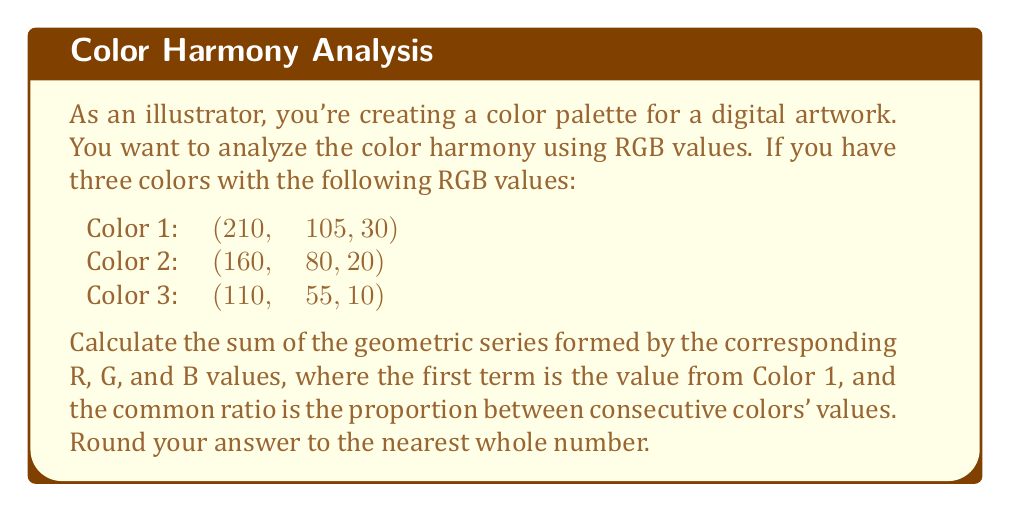Show me your answer to this math problem. Let's approach this step-by-step:

1) First, we need to identify the common ratio (r) for each color channel:

   For R: $r_R = 160/210 = 110/160 \approx 0.7619$
   For G: $r_G = 80/105 = 55/80 \approx 0.7619$
   For B: $r_B = 20/30 = 10/20 \approx 0.6667$

2) Now, we have three geometric series:
   
   R: $210 + 210(0.7619) + 210(0.7619)^2 + ...$
   G: $105 + 105(0.7619) + 105(0.7619)^2 + ...$
   B: $30 + 30(0.6667) + 30(0.6667)^2 + ...$

3) The sum of an infinite geometric series is given by the formula:
   
   $S_{\infty} = \frac{a}{1-r}$, where $a$ is the first term and $r$ is the common ratio

4) Let's calculate the sum for each series:

   R: $S_R = \frac{210}{1-0.7619} \approx 882.35$
   G: $S_G = \frac{105}{1-0.7619} \approx 441.18$
   B: $S_B = \frac{30}{1-0.6667} = 90$

5) The total sum is:

   $S_{total} = S_R + S_G + S_B \approx 882.35 + 441.18 + 90 = 1413.53$

6) Rounding to the nearest whole number:

   $S_{total} \approx 1414$
Answer: 1414 